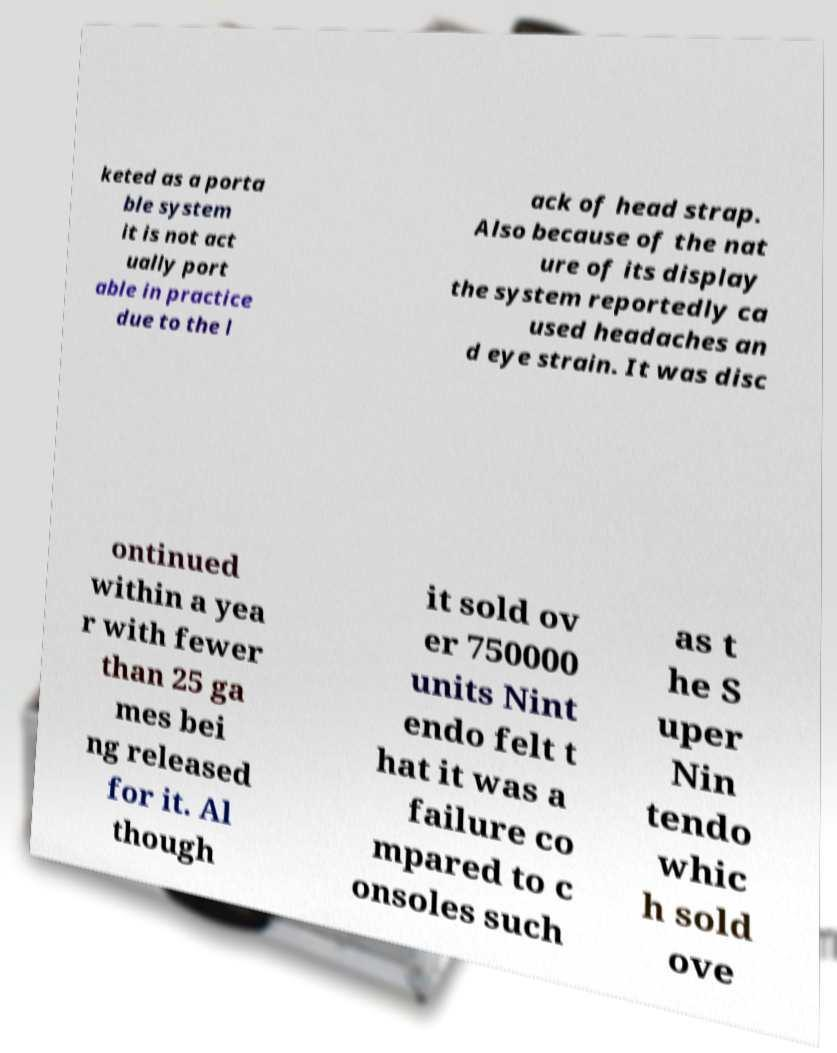Please read and relay the text visible in this image. What does it say? keted as a porta ble system it is not act ually port able in practice due to the l ack of head strap. Also because of the nat ure of its display the system reportedly ca used headaches an d eye strain. It was disc ontinued within a yea r with fewer than 25 ga mes bei ng released for it. Al though it sold ov er 750000 units Nint endo felt t hat it was a failure co mpared to c onsoles such as t he S uper Nin tendo whic h sold ove 